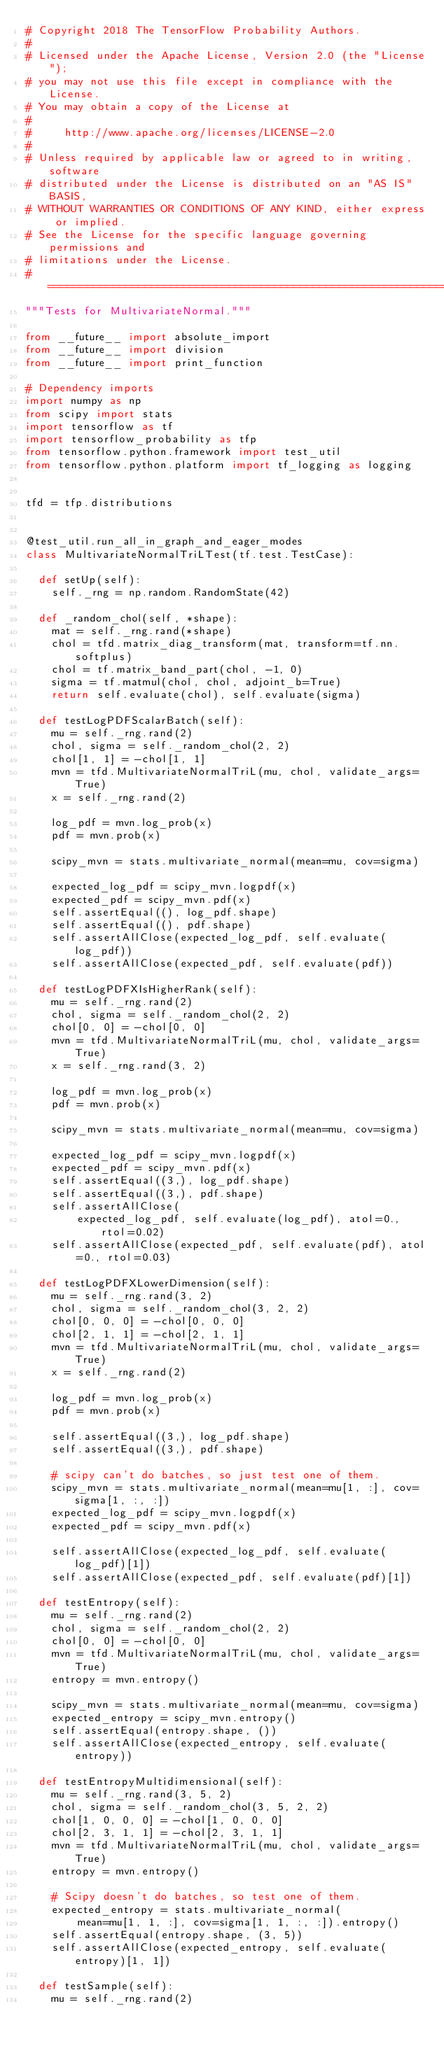Convert code to text. <code><loc_0><loc_0><loc_500><loc_500><_Python_># Copyright 2018 The TensorFlow Probability Authors.
#
# Licensed under the Apache License, Version 2.0 (the "License");
# you may not use this file except in compliance with the License.
# You may obtain a copy of the License at
#
#     http://www.apache.org/licenses/LICENSE-2.0
#
# Unless required by applicable law or agreed to in writing, software
# distributed under the License is distributed on an "AS IS" BASIS,
# WITHOUT WARRANTIES OR CONDITIONS OF ANY KIND, either express or implied.
# See the License for the specific language governing permissions and
# limitations under the License.
# ============================================================================
"""Tests for MultivariateNormal."""

from __future__ import absolute_import
from __future__ import division
from __future__ import print_function

# Dependency imports
import numpy as np
from scipy import stats
import tensorflow as tf
import tensorflow_probability as tfp
from tensorflow.python.framework import test_util
from tensorflow.python.platform import tf_logging as logging


tfd = tfp.distributions


@test_util.run_all_in_graph_and_eager_modes
class MultivariateNormalTriLTest(tf.test.TestCase):

  def setUp(self):
    self._rng = np.random.RandomState(42)

  def _random_chol(self, *shape):
    mat = self._rng.rand(*shape)
    chol = tfd.matrix_diag_transform(mat, transform=tf.nn.softplus)
    chol = tf.matrix_band_part(chol, -1, 0)
    sigma = tf.matmul(chol, chol, adjoint_b=True)
    return self.evaluate(chol), self.evaluate(sigma)

  def testLogPDFScalarBatch(self):
    mu = self._rng.rand(2)
    chol, sigma = self._random_chol(2, 2)
    chol[1, 1] = -chol[1, 1]
    mvn = tfd.MultivariateNormalTriL(mu, chol, validate_args=True)
    x = self._rng.rand(2)

    log_pdf = mvn.log_prob(x)
    pdf = mvn.prob(x)

    scipy_mvn = stats.multivariate_normal(mean=mu, cov=sigma)

    expected_log_pdf = scipy_mvn.logpdf(x)
    expected_pdf = scipy_mvn.pdf(x)
    self.assertEqual((), log_pdf.shape)
    self.assertEqual((), pdf.shape)
    self.assertAllClose(expected_log_pdf, self.evaluate(log_pdf))
    self.assertAllClose(expected_pdf, self.evaluate(pdf))

  def testLogPDFXIsHigherRank(self):
    mu = self._rng.rand(2)
    chol, sigma = self._random_chol(2, 2)
    chol[0, 0] = -chol[0, 0]
    mvn = tfd.MultivariateNormalTriL(mu, chol, validate_args=True)
    x = self._rng.rand(3, 2)

    log_pdf = mvn.log_prob(x)
    pdf = mvn.prob(x)

    scipy_mvn = stats.multivariate_normal(mean=mu, cov=sigma)

    expected_log_pdf = scipy_mvn.logpdf(x)
    expected_pdf = scipy_mvn.pdf(x)
    self.assertEqual((3,), log_pdf.shape)
    self.assertEqual((3,), pdf.shape)
    self.assertAllClose(
        expected_log_pdf, self.evaluate(log_pdf), atol=0., rtol=0.02)
    self.assertAllClose(expected_pdf, self.evaluate(pdf), atol=0., rtol=0.03)

  def testLogPDFXLowerDimension(self):
    mu = self._rng.rand(3, 2)
    chol, sigma = self._random_chol(3, 2, 2)
    chol[0, 0, 0] = -chol[0, 0, 0]
    chol[2, 1, 1] = -chol[2, 1, 1]
    mvn = tfd.MultivariateNormalTriL(mu, chol, validate_args=True)
    x = self._rng.rand(2)

    log_pdf = mvn.log_prob(x)
    pdf = mvn.prob(x)

    self.assertEqual((3,), log_pdf.shape)
    self.assertEqual((3,), pdf.shape)

    # scipy can't do batches, so just test one of them.
    scipy_mvn = stats.multivariate_normal(mean=mu[1, :], cov=sigma[1, :, :])
    expected_log_pdf = scipy_mvn.logpdf(x)
    expected_pdf = scipy_mvn.pdf(x)

    self.assertAllClose(expected_log_pdf, self.evaluate(log_pdf)[1])
    self.assertAllClose(expected_pdf, self.evaluate(pdf)[1])

  def testEntropy(self):
    mu = self._rng.rand(2)
    chol, sigma = self._random_chol(2, 2)
    chol[0, 0] = -chol[0, 0]
    mvn = tfd.MultivariateNormalTriL(mu, chol, validate_args=True)
    entropy = mvn.entropy()

    scipy_mvn = stats.multivariate_normal(mean=mu, cov=sigma)
    expected_entropy = scipy_mvn.entropy()
    self.assertEqual(entropy.shape, ())
    self.assertAllClose(expected_entropy, self.evaluate(entropy))

  def testEntropyMultidimensional(self):
    mu = self._rng.rand(3, 5, 2)
    chol, sigma = self._random_chol(3, 5, 2, 2)
    chol[1, 0, 0, 0] = -chol[1, 0, 0, 0]
    chol[2, 3, 1, 1] = -chol[2, 3, 1, 1]
    mvn = tfd.MultivariateNormalTriL(mu, chol, validate_args=True)
    entropy = mvn.entropy()

    # Scipy doesn't do batches, so test one of them.
    expected_entropy = stats.multivariate_normal(
        mean=mu[1, 1, :], cov=sigma[1, 1, :, :]).entropy()
    self.assertEqual(entropy.shape, (3, 5))
    self.assertAllClose(expected_entropy, self.evaluate(entropy)[1, 1])

  def testSample(self):
    mu = self._rng.rand(2)</code> 